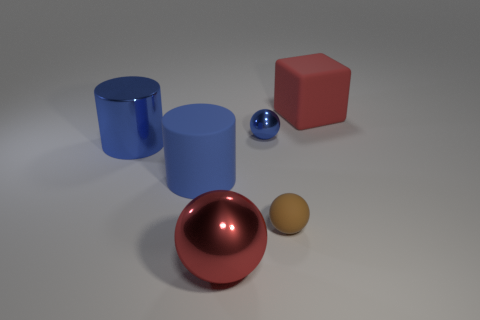Add 4 big balls. How many objects exist? 10 Subtract all cylinders. How many objects are left? 4 Add 4 rubber cylinders. How many rubber cylinders are left? 5 Add 1 cyan rubber spheres. How many cyan rubber spheres exist? 1 Subtract 0 purple balls. How many objects are left? 6 Subtract all large gray rubber cylinders. Subtract all big rubber objects. How many objects are left? 4 